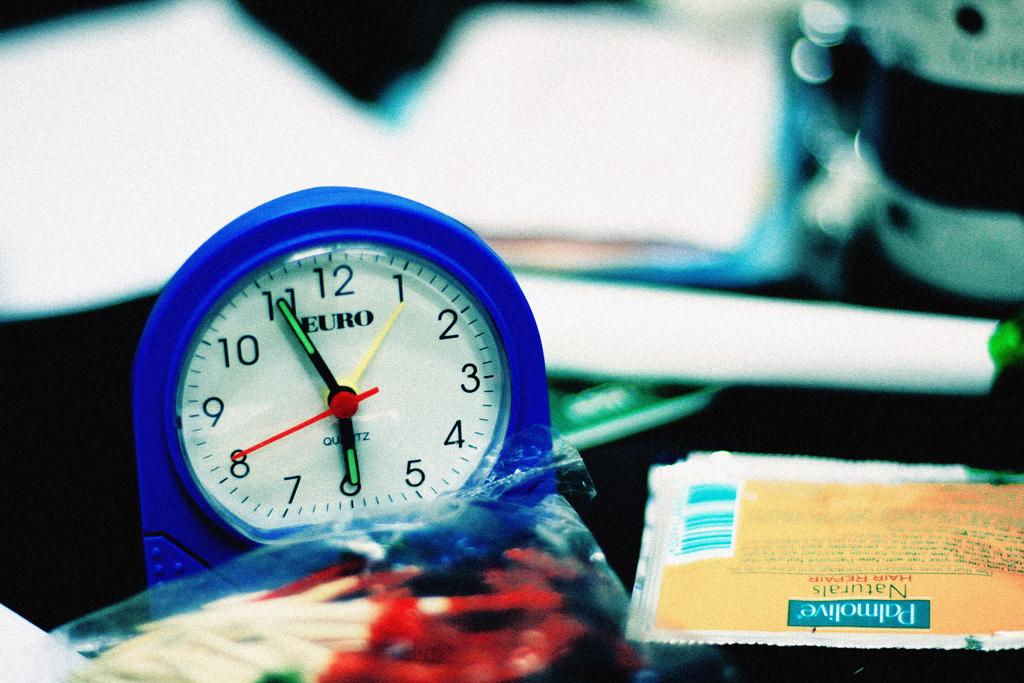Provide a one-sentence caption for the provided image. A Euro clock is next to a Palmolive hair repair packet. 